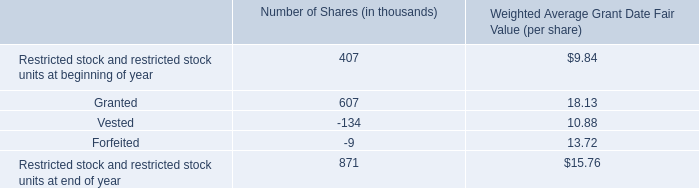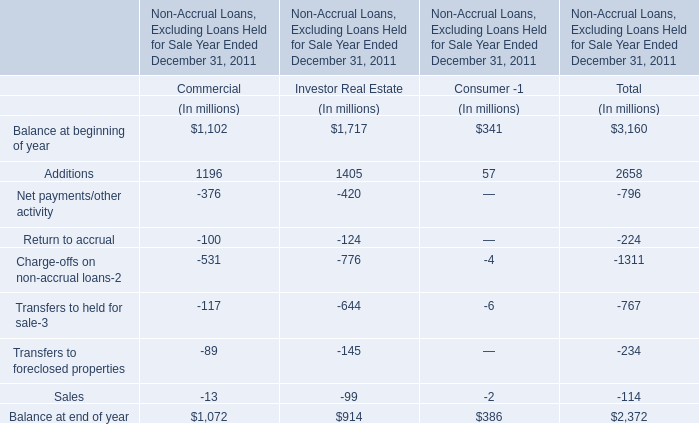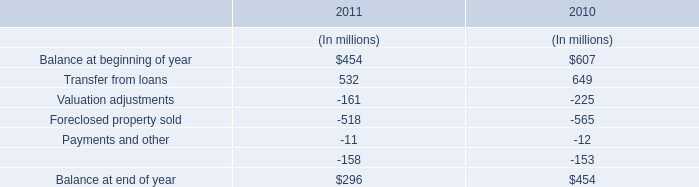What's the 20 % of total elements for Commercial in 2011? (in million) 
Computations: (1072 * 0.2)
Answer: 214.4. 